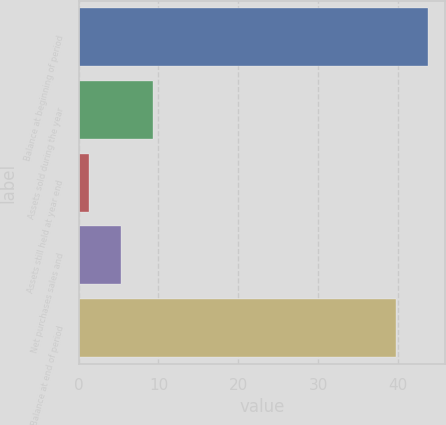<chart> <loc_0><loc_0><loc_500><loc_500><bar_chart><fcel>Balance at beginning of period<fcel>Assets sold during the year<fcel>Assets still held at year end<fcel>Net purchases sales and<fcel>Balance at end of period<nl><fcel>43.78<fcel>9.26<fcel>1.3<fcel>5.28<fcel>39.8<nl></chart> 